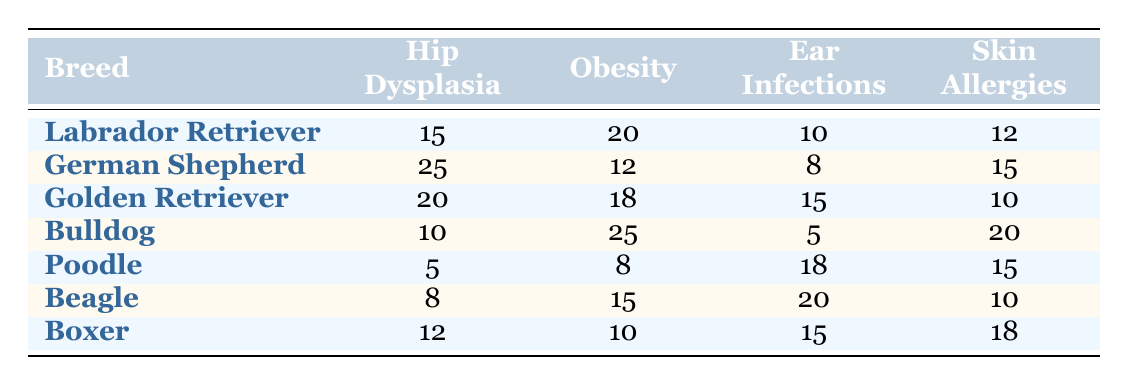What is the total number of dogs with Hip Dysplasia among all breeds? Adding the numbers for Hip Dysplasia from each breed: 15 (Labrador Retriever) + 25 (German Shepherd) + 20 (Golden Retriever) + 10 (Bulldog) + 5 (Poodle) + 8 (Beagle) + 12 (Boxer) = 105
Answer: 105 Which breed has the highest number of dogs suffering from Obesity? Looking at the Obesity column, the highest number is 25 for the Bulldog.
Answer: Bulldog How many breeds have more than 15 cases of Ear Infections? Counting the breeds with Ear Infections greater than 15: Beagle (20), Poodle (18), Golden Retriever (15), Boxer (15). The breeds with more than 15 are Beagle and Poodle, so there are 2 breeds.
Answer: 2 What is the average number of cases for Skin Allergies across all breeds? The total number of Skin Allergies is: 12 (Labrador Retriever) + 15 (German Shepherd) + 10 (Golden Retriever) + 20 (Bulldog) + 15 (Poodle) + 10 (Beagle) + 18 (Boxer) = 100. There are 7 breeds, thus the average is 100/7 ≈ 14.29.
Answer: Approximately 14.29 Is it true that more breeds have cases of Ear Infections than Skin Allergies? The count of breeds with Ear Infections greater than 10 is: Labrador Retriever (10), German Shepherd (8), Golden Retriever (15), Bulldog (5), Poodle (18), Beagle (20), Boxer (15) which totals to 5. The number of breeds with Skin Allergies greater than 10 is also Labrador Retriever (12), German Shepherd (15), Bulldog (20), Poodle (15), Beagle (10), Boxer (18) equaling 5 as well. Thus, both counts are equal.
Answer: No What is the difference in the number of cases of Hip Dysplasia between the German Shepherd and the Boxer? The number of cases is 25 for German Shepherd and 12 for Boxer. The difference is 25 - 12 = 13.
Answer: 13 